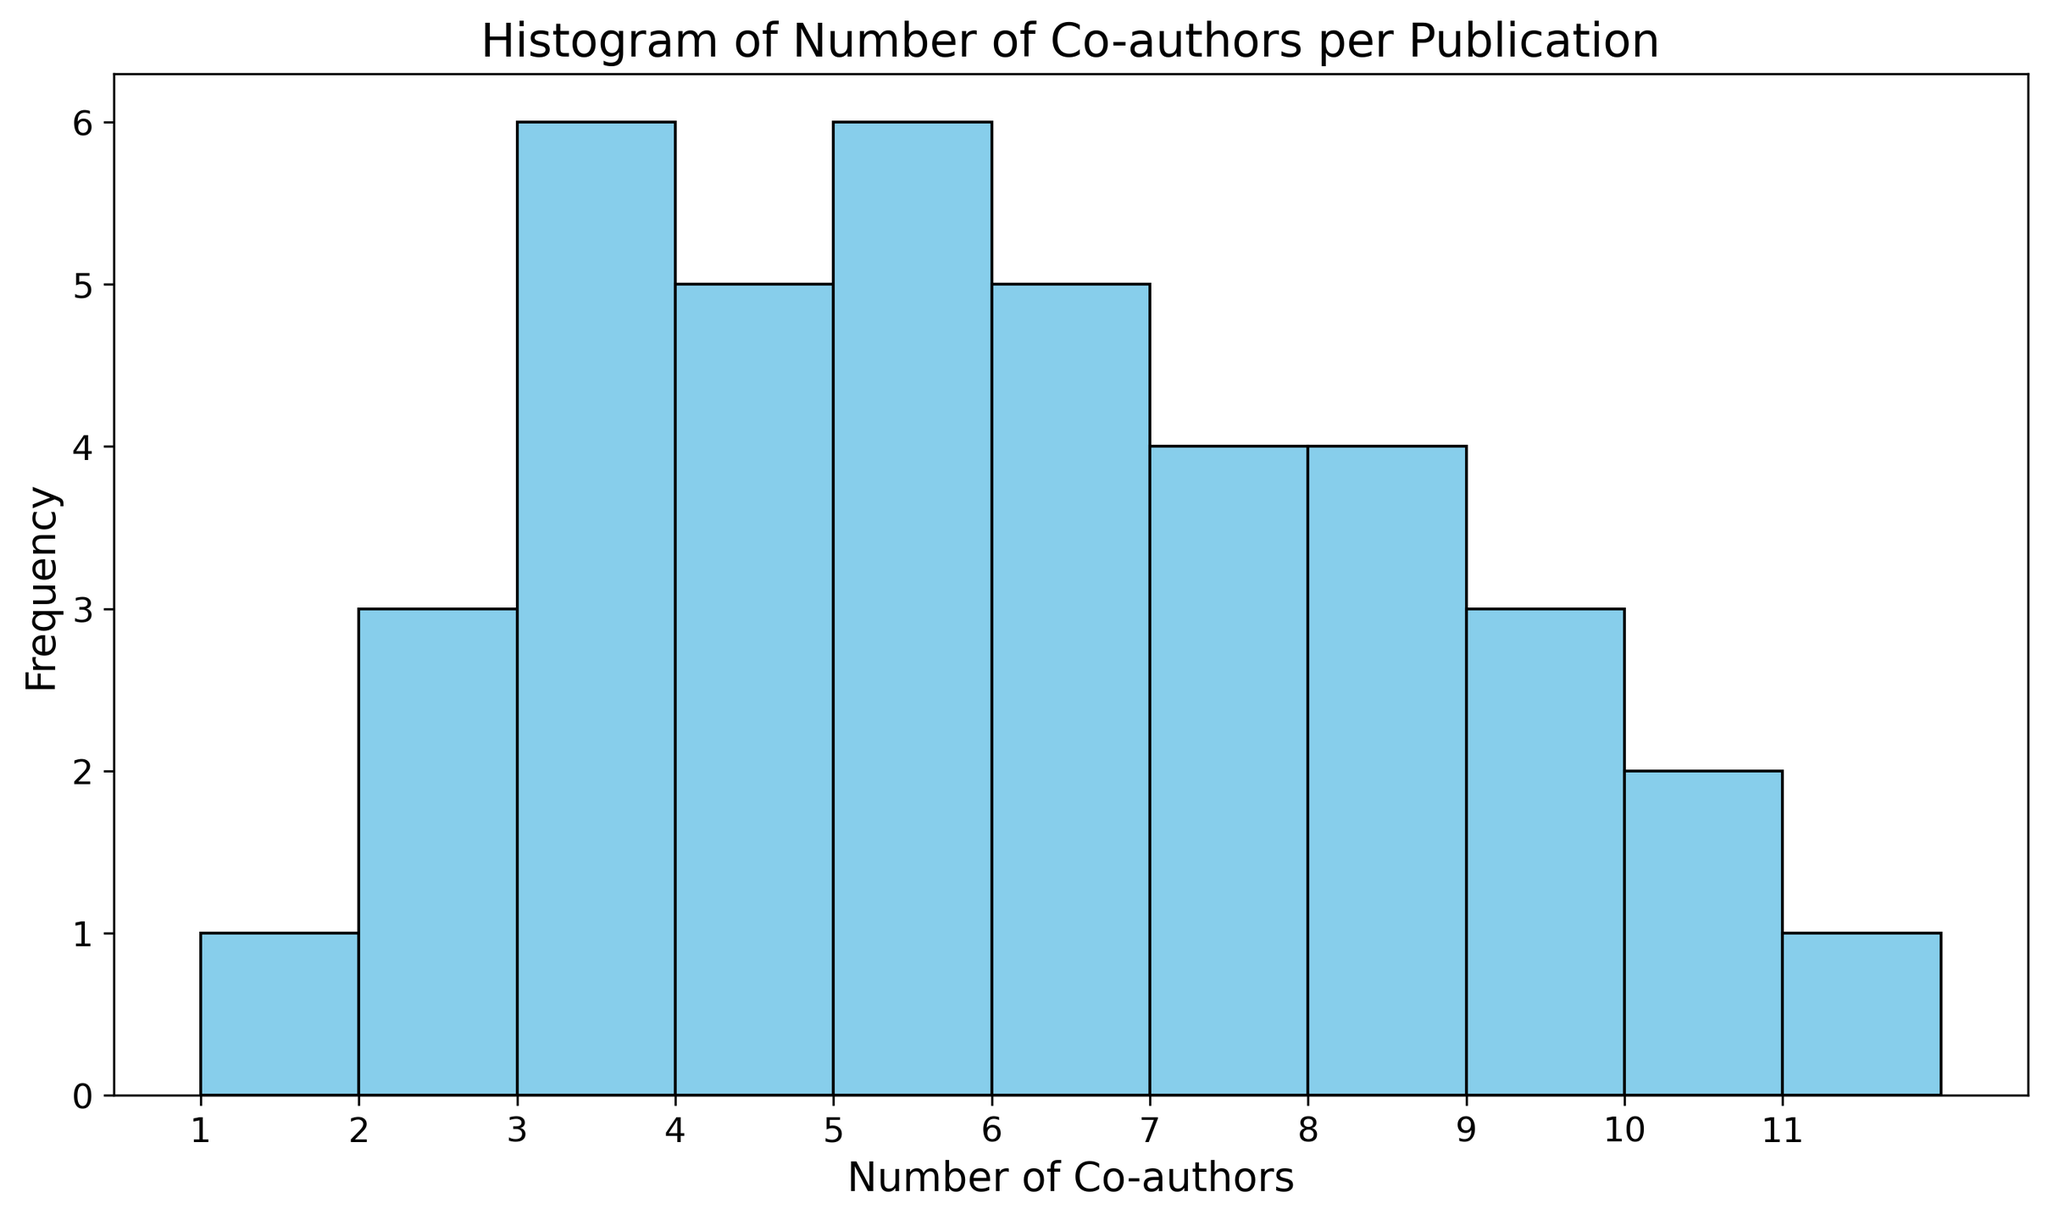What is the most frequent number of co-authors? By examining the histogram, the highest bar indicates the most frequent number of co-authors. The bar corresponding to 5 co-authors is the tallest.
Answer: 5 How many publications have exactly 7 co-authors? Count the height of the bar corresponding to 7 co-authors. The histogram shows that there are four publications with 7 co-authors.
Answer: 4 Which number of co-authors appeared least frequently? Identify the shortest bars on the histogram. The histogram shows that 1 co-author and 11 co-authors are the least frequent, each appearing only once.
Answer: 1, 11 How many publications have more than 8 co-authors? Count the height of the bars corresponding to co-authors greater than 8. The histogram shows that there are three publications with 9 co-authors, two publications with 10 co-authors, and one publication with 11 co-authors, so 3 + 2 + 1 = 6.
Answer: 6 What is the difference in the number of publications between 4 and 6 co-authors? Note the height of the bars corresponding to 4 and 6 co-authors. There are five publications with 4 co-authors and five publications with 6 co-authors and the difference is 5 - 5 = 0.
Answer: 0 Which number of co-authors has a similar frequency to 3 co-authors? Identify the heights of the bars. The bar for 4 co-authors is also quite close in height to the bar for 3 co-authors. Both have a frequency of 5.
Answer: 4 